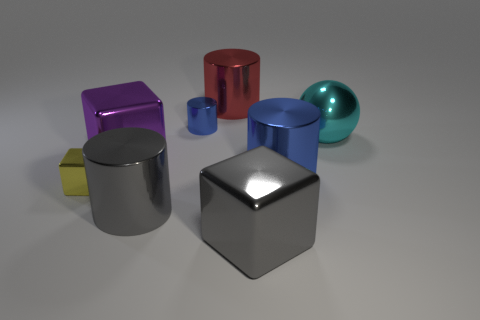Add 2 large brown things. How many objects exist? 10 Subtract all cubes. How many objects are left? 5 Add 1 yellow shiny objects. How many yellow shiny objects exist? 2 Subtract 0 green cubes. How many objects are left? 8 Subtract all metallic spheres. Subtract all blue shiny cylinders. How many objects are left? 5 Add 6 big metal cubes. How many big metal cubes are left? 8 